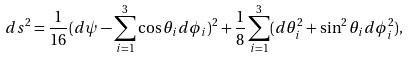Convert formula to latex. <formula><loc_0><loc_0><loc_500><loc_500>d s ^ { 2 } = \frac { 1 } { 1 6 } ( d \psi - \sum _ { i = 1 } ^ { 3 } \cos \theta _ { i } d \phi _ { i } ) ^ { 2 } + \frac { 1 } { 8 } \sum _ { i = 1 } ^ { 3 } ( d \theta _ { i } ^ { 2 } + \sin ^ { 2 } \theta _ { i } d \phi _ { i } ^ { 2 } ) ,</formula> 